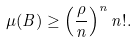Convert formula to latex. <formula><loc_0><loc_0><loc_500><loc_500>\mu ( B ) \geq \left ( \frac { \rho } { n } \right ) ^ { n } n ! .</formula> 